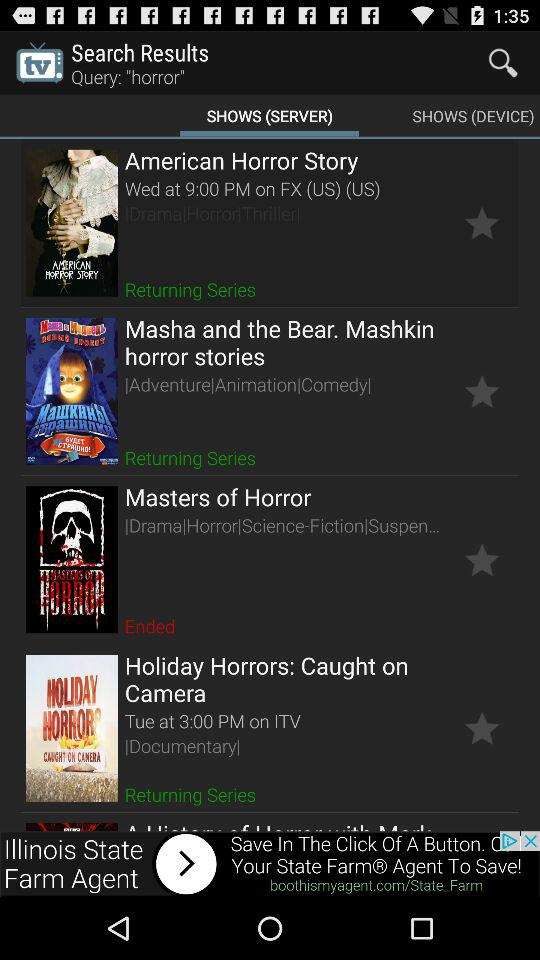What is the show time of "Holiday Horrors: Caught on Camera"? The show time is on Tuesday at 3:00 PM. 